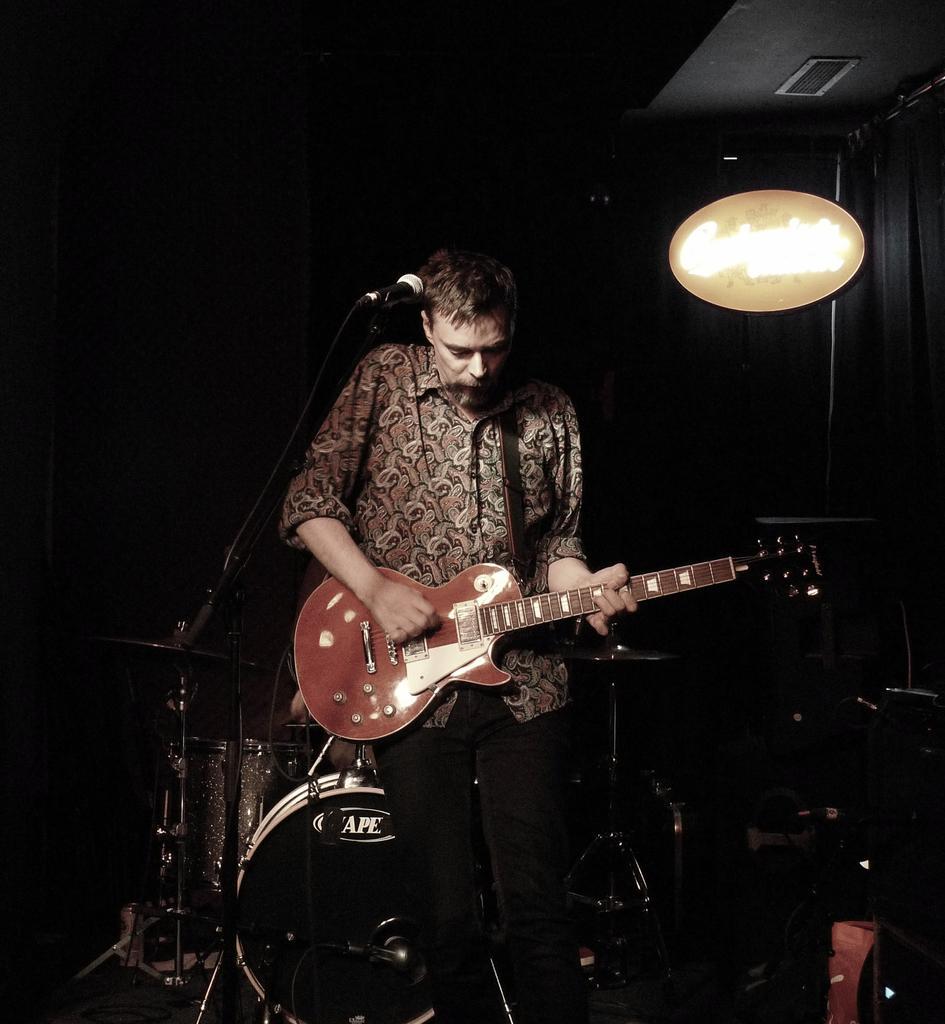Please provide a concise description of this image. The picture consists of one man standing wearing brown shirt and black pant, playing guitar in front of the microphone and behind him there are drums and black curtain with some board on it. 